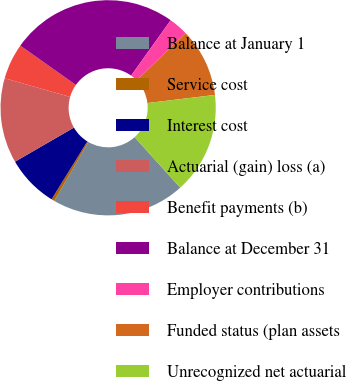<chart> <loc_0><loc_0><loc_500><loc_500><pie_chart><fcel>Balance at January 1<fcel>Service cost<fcel>Interest cost<fcel>Actuarial (gain) loss (a)<fcel>Benefit payments (b)<fcel>Balance at December 31<fcel>Employer contributions<fcel>Funded status (plan assets<fcel>Unrecognized net actuarial<nl><fcel>20.03%<fcel>0.46%<fcel>7.84%<fcel>12.77%<fcel>5.38%<fcel>25.07%<fcel>2.92%<fcel>10.3%<fcel>15.23%<nl></chart> 